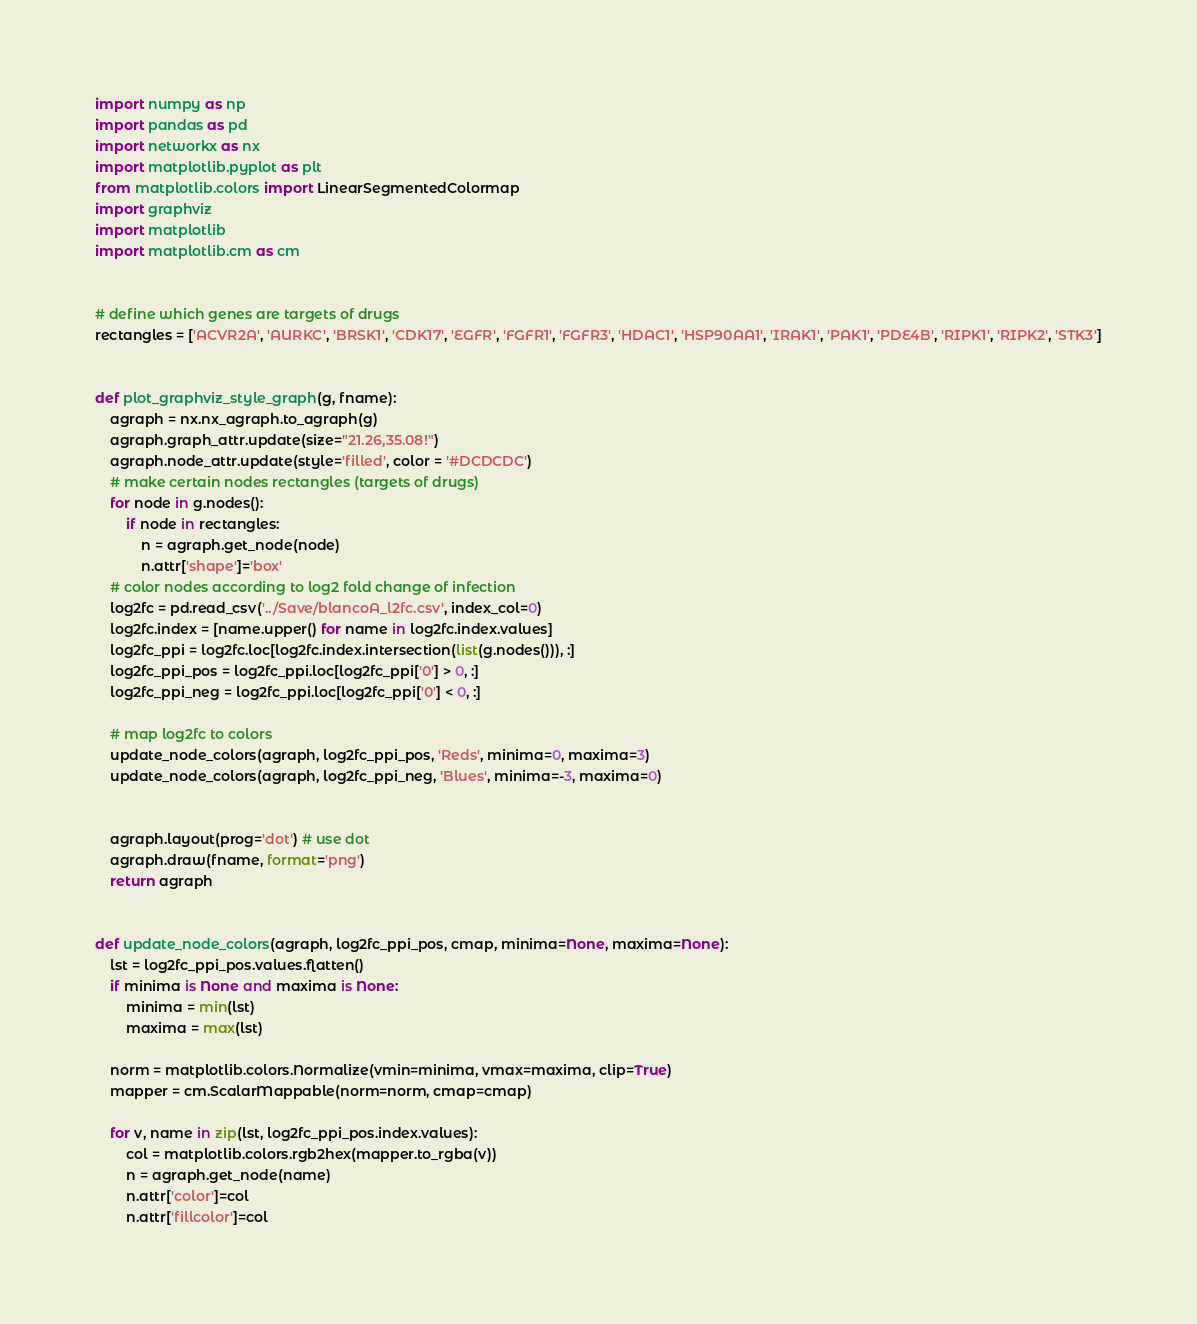Convert code to text. <code><loc_0><loc_0><loc_500><loc_500><_Python_>import numpy as np
import pandas as pd
import networkx as nx
import matplotlib.pyplot as plt
from matplotlib.colors import LinearSegmentedColormap
import graphviz
import matplotlib
import matplotlib.cm as cm


# define which genes are targets of drugs
rectangles = ['ACVR2A', 'AURKC', 'BRSK1', 'CDK17', 'EGFR', 'FGFR1', 'FGFR3', 'HDAC1', 'HSP90AA1', 'IRAK1', 'PAK1', 'PDE4B', 'RIPK1', 'RIPK2', 'STK3']


def plot_graphviz_style_graph(g, fname):
	agraph = nx.nx_agraph.to_agraph(g)
	agraph.graph_attr.update(size="21.26,35.08!")
	agraph.node_attr.update(style='filled', color = '#DCDCDC')
	# make certain nodes rectangles (targets of drugs)
	for node in g.nodes():
		if node in rectangles:
			n = agraph.get_node(node)
			n.attr['shape']='box'
	# color nodes according to log2 fold change of infection
	log2fc = pd.read_csv('../Save/blancoA_l2fc.csv', index_col=0)
	log2fc.index = [name.upper() for name in log2fc.index.values]
	log2fc_ppi = log2fc.loc[log2fc.index.intersection(list(g.nodes())), :]
	log2fc_ppi_pos = log2fc_ppi.loc[log2fc_ppi['0'] > 0, :]
	log2fc_ppi_neg = log2fc_ppi.loc[log2fc_ppi['0'] < 0, :]

	# map log2fc to colors
	update_node_colors(agraph, log2fc_ppi_pos, 'Reds', minima=0, maxima=3)
	update_node_colors(agraph, log2fc_ppi_neg, 'Blues', minima=-3, maxima=0)
	

	agraph.layout(prog='dot') # use dot
	agraph.draw(fname, format='png')
	return agraph


def update_node_colors(agraph, log2fc_ppi_pos, cmap, minima=None, maxima=None):
	lst = log2fc_ppi_pos.values.flatten()
	if minima is None and maxima is None:
		minima = min(lst)
		maxima = max(lst)

	norm = matplotlib.colors.Normalize(vmin=minima, vmax=maxima, clip=True)
	mapper = cm.ScalarMappable(norm=norm, cmap=cmap)

	for v, name in zip(lst, log2fc_ppi_pos.index.values):
		col = matplotlib.colors.rgb2hex(mapper.to_rgba(v))
		n = agraph.get_node(name)
		n.attr['color']=col
		n.attr['fillcolor']=col</code> 